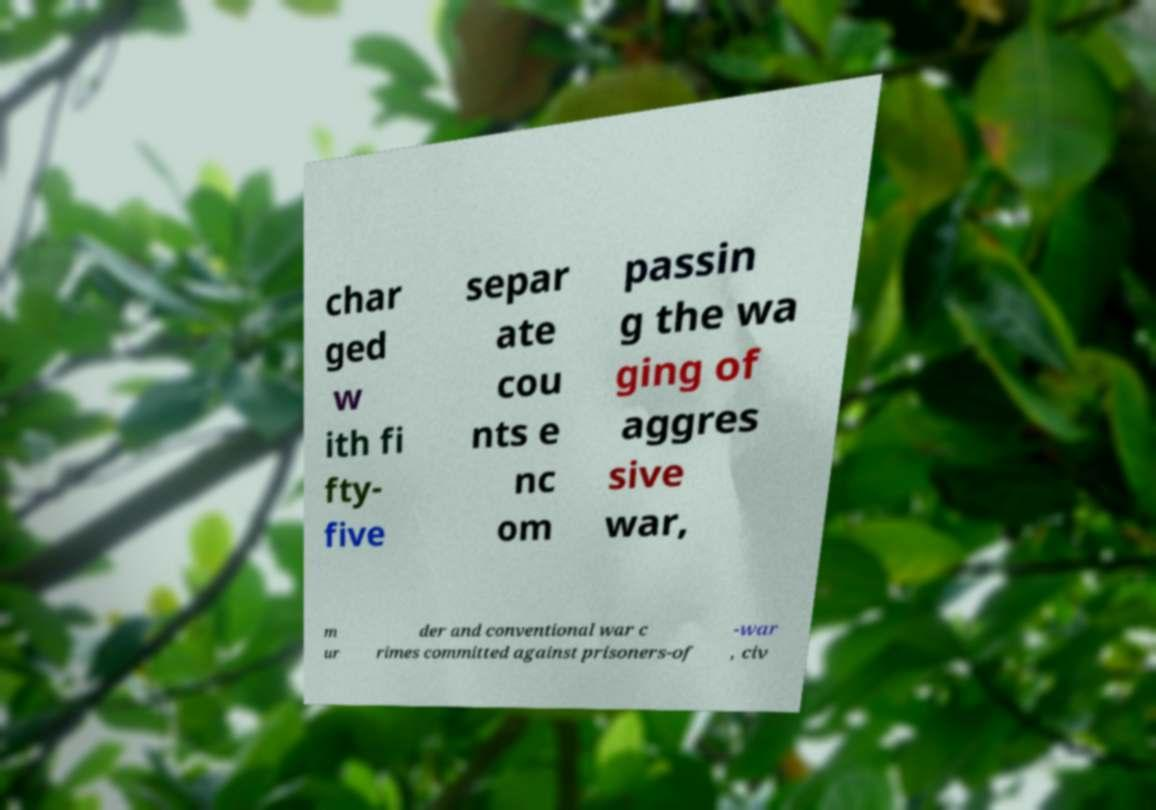Please identify and transcribe the text found in this image. char ged w ith fi fty- five separ ate cou nts e nc om passin g the wa ging of aggres sive war, m ur der and conventional war c rimes committed against prisoners-of -war , civ 